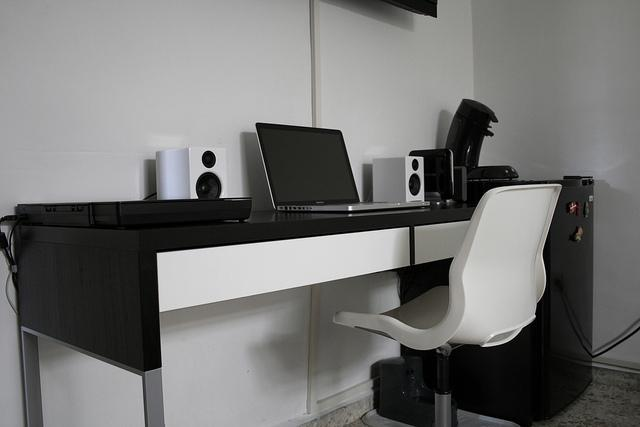Which object in the room can create the most noise? speakers 